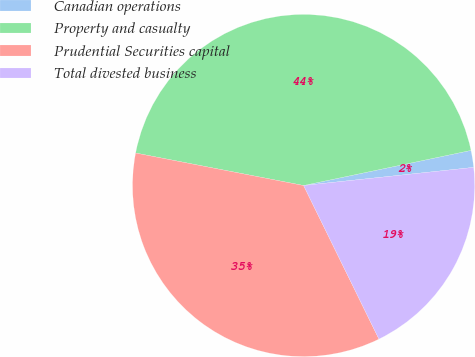<chart> <loc_0><loc_0><loc_500><loc_500><pie_chart><fcel>Canadian operations<fcel>Property and casualty<fcel>Prudential Securities capital<fcel>Total divested business<nl><fcel>1.6%<fcel>43.67%<fcel>35.3%<fcel>19.43%<nl></chart> 